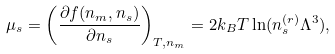Convert formula to latex. <formula><loc_0><loc_0><loc_500><loc_500>\mu _ { s } = \left ( \frac { \partial f ( n _ { m } , n _ { s } ) } { \partial n _ { s } } \right ) _ { T , n _ { m } } = 2 k _ { B } T \ln ( n _ { s } ^ { ( r ) } \Lambda ^ { 3 } ) ,</formula> 